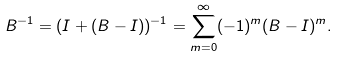<formula> <loc_0><loc_0><loc_500><loc_500>B ^ { - 1 } = ( I + ( B - I ) ) ^ { - 1 } = \sum _ { m = 0 } ^ { \infty } ( - 1 ) ^ { m } ( B - I ) ^ { m } .</formula> 